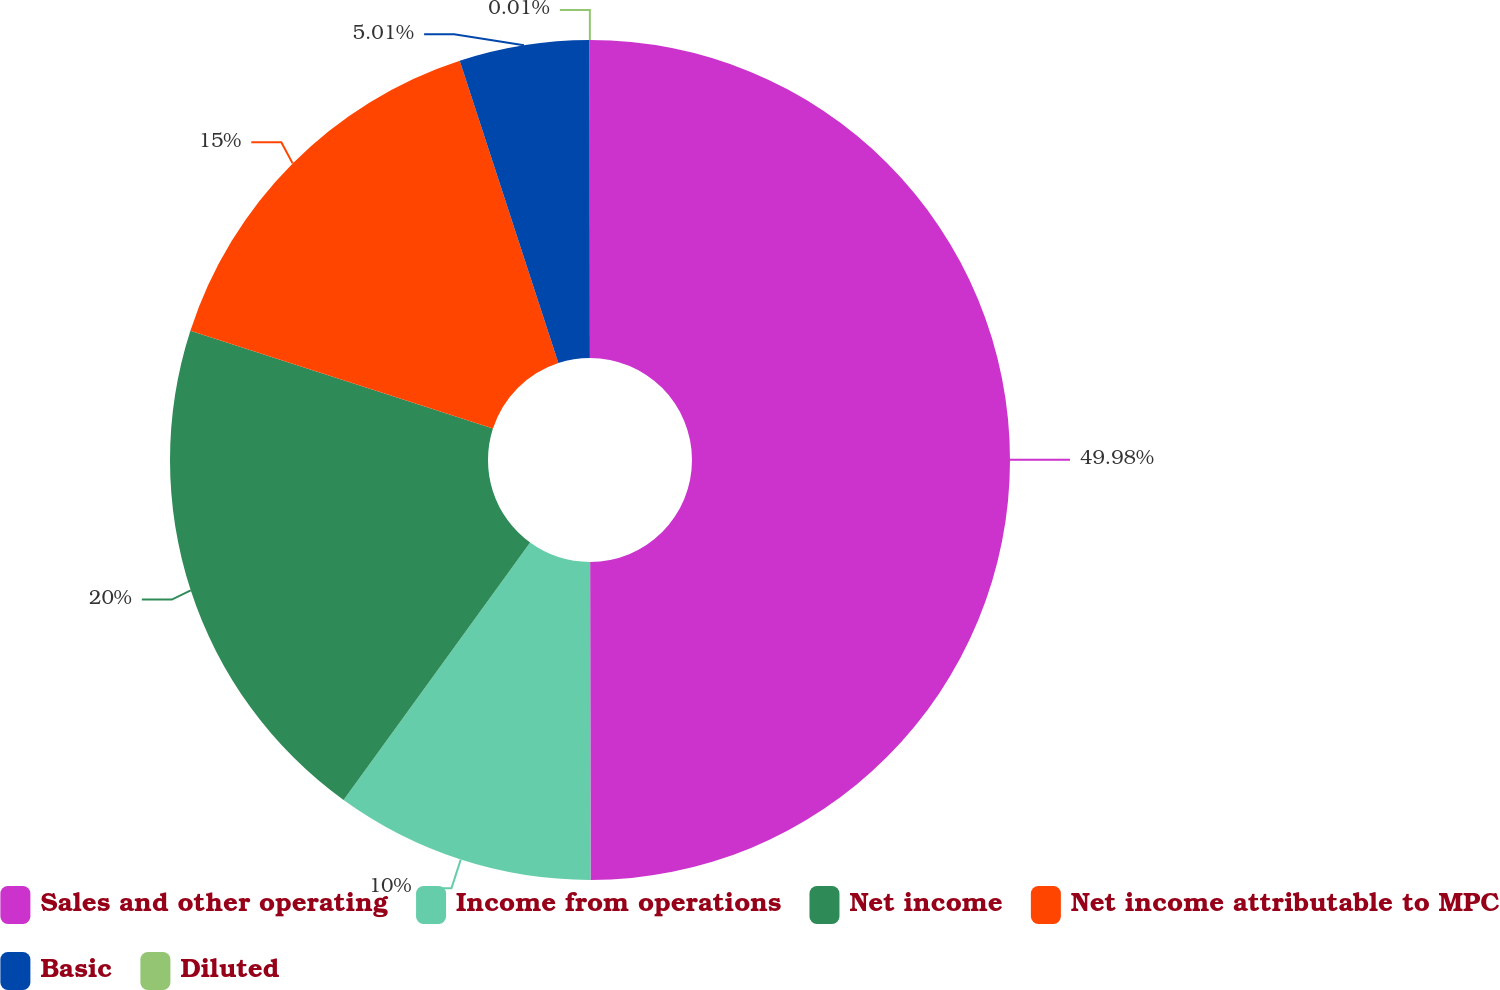Convert chart. <chart><loc_0><loc_0><loc_500><loc_500><pie_chart><fcel>Sales and other operating<fcel>Income from operations<fcel>Net income<fcel>Net income attributable to MPC<fcel>Basic<fcel>Diluted<nl><fcel>49.98%<fcel>10.0%<fcel>20.0%<fcel>15.0%<fcel>5.01%<fcel>0.01%<nl></chart> 